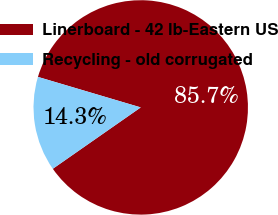<chart> <loc_0><loc_0><loc_500><loc_500><pie_chart><fcel>Linerboard - 42 lb-Eastern US<fcel>Recycling - old corrugated<nl><fcel>85.71%<fcel>14.29%<nl></chart> 